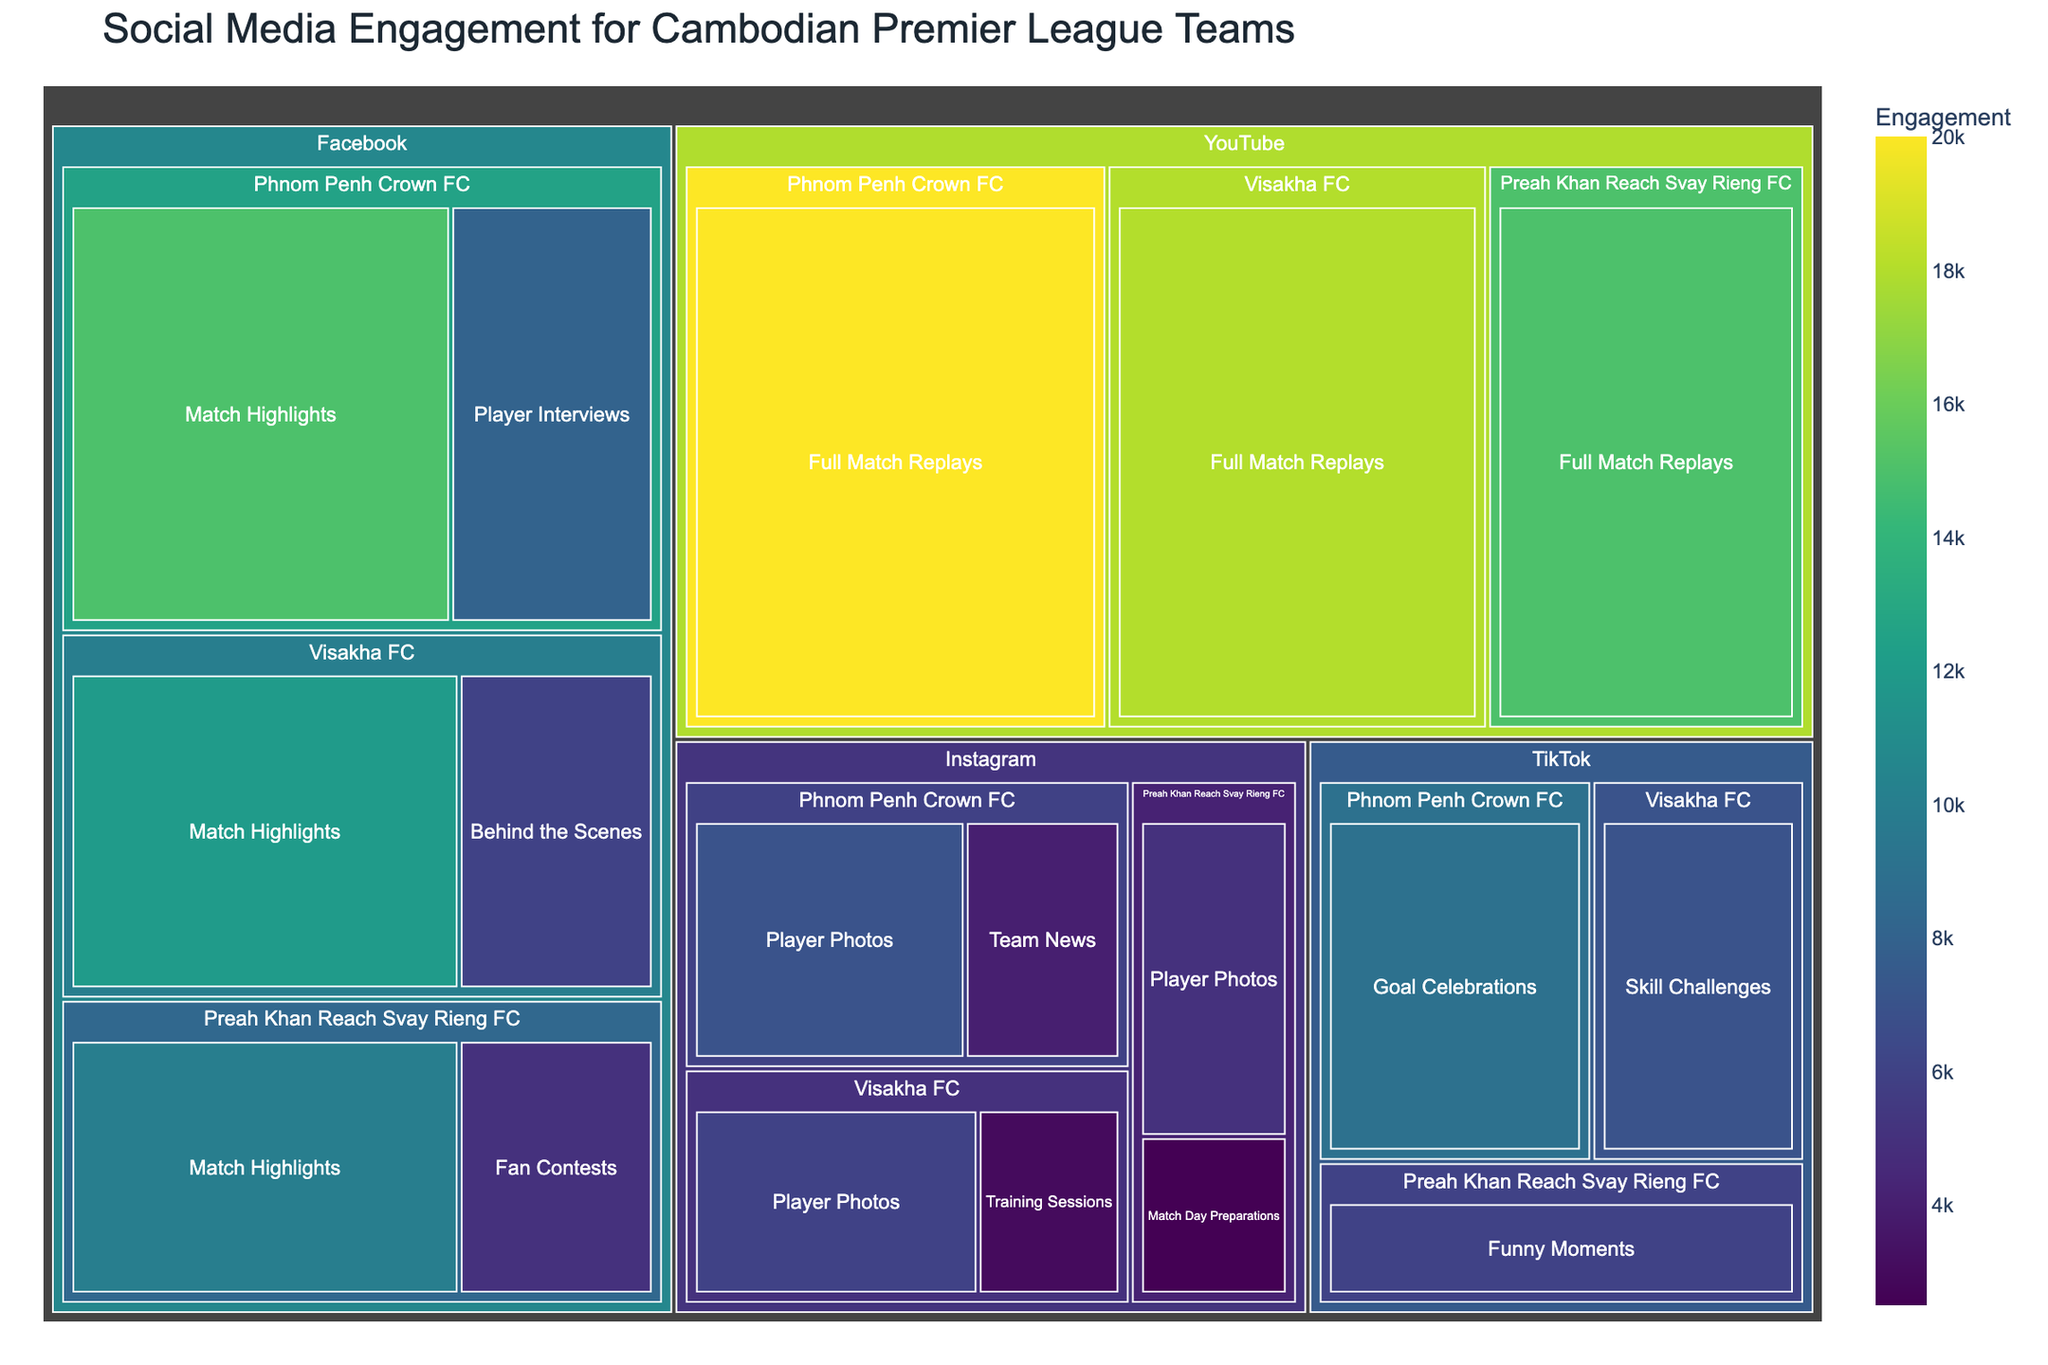What is the total social media engagement for Phnom Penh Crown FC on Facebook? To find the total engagement, sum up all engagements listed under "Phnom Penh Crown FC" and "Facebook". These are 15,000 for Match Highlights and 8,000 for Player Interviews. 15000 + 8000 = 23,000
Answer: 23,000 Which team has the highest engagement on YouTube? Determine the engagement values for each team on YouTube. Phnom Penh Crown FC has 20,000, Visakha FC has 18,000, and Preah Khan Reach Svay Rieng FC has 15,000. The highest value is for Phnom Penh Crown FC.
Answer: Phnom Penh Crown FC How much more engagement does the Match Highlights content have compared to Player Interviews on Facebook for Phnom Penh Crown FC? Match Highlights have 15,000 engagements and Player Interviews have 8,000 engagements for Phnom Penh Crown FC on Facebook. The difference is 15000 - 8000 = 7,000
Answer: 7,000 Which platform has the highest engagement for Phnom Penh Crown FC? Compare the total engagements for Phnom Penh Crown FC across all platforms. Facebook: 23,000, Instagram: 11,000, YouTube: 20,000, TikTok: 9,000. The greatest total is for Facebook.
Answer: Facebook What's the average engagement per content type on Instagram for Visakha FC? List the engagement values for each content type for Visakha FC on Instagram: Player Photos (6,000) and Training Sessions (3,000). Total engagements = 6,000 + 3,000 = 9,000. Number of content types = 2. Average = 9,000 / 2 = 4,500
Answer: 4,500 Which team has the least engagement on TikTok? Compare the engagement values on TikTok: Phnom Penh Crown FC (9,000), Visakha FC (7,000), Preah Khan Reach Svay Rieng FC (6,000). The least value is 6,000 for Preah Khan Reach Svay Rieng FC.
Answer: Preah Khan Reach Svay Rieng FC What is the most engaging content type across all teams on YouTube? Compare engagement values of content types on YouTube for all teams. Full Match Replays have 20,000 (Phnom Penh Crown FC), 18,000 (Visakha FC), and 15,000 (Preah Khan Reach Svay Rieng FC). Full Match Replays have the highest engagement overall.
Answer: Full Match Replays How do the engagements for Player Photos compare between Instagram and TikTok for any team? Compare engagement values for Player Photos on Instagram and TikTok. For Phnom Penh Crown FC on Instagram, Player Photos have 7,000 engagements, and TikTok doesn't list Player Photos, so only Instagram has this content type. Visakha FC: Instagram 6,000, TikTok doesn’t list. Preah Khan Reach Svay Rieng FC: Instagram 5,000, TikTok doesn’t list. Consequently, only Instagram lists Player Photos, making it higher by default.
Answer: Higher on Instagram What is the total engagement across all platforms for Preah Khan Reach Svay Rieng FC? Sum all engagement values for Preah Khan Reach Svay Rieng FC across all platforms. Facebook: 10,000 + 5,000 = 15,000. Instagram: 5,000 + 2,500 = 7,500. YouTube: 15,000. TikTok: 6,000. Total = 15,000 + 7,500 + 15,000 + 6,000 = 43,500
Answer: 43,500 Which team has the highest engagement for Match Highlights on Facebook? Compare the engagement values for Match Highlights on Facebook: Phnom Penh Crown FC (15,000), Visakha FC (12,000), Preah Khan Reach Svay Rieng FC (10,000). The highest value is 15,000 for Phnom Penh Crown FC.
Answer: Phnom Penh Crown FC 